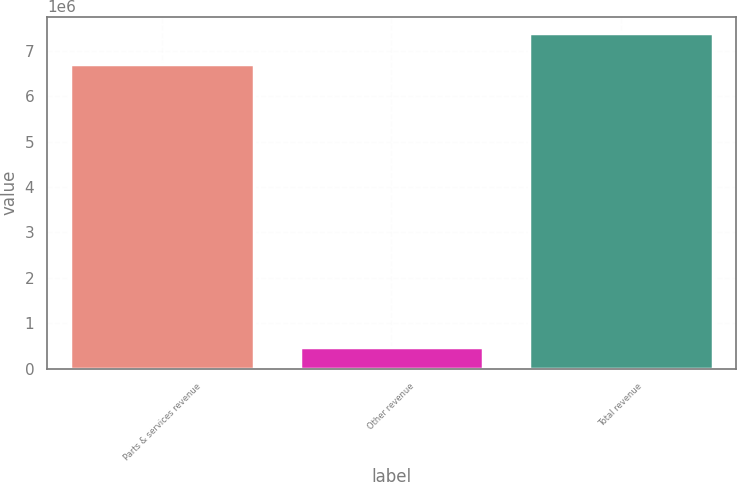Convert chart. <chart><loc_0><loc_0><loc_500><loc_500><bar_chart><fcel>Parts & services revenue<fcel>Other revenue<fcel>Total revenue<nl><fcel>6.71395e+06<fcel>478682<fcel>7.38535e+06<nl></chart> 